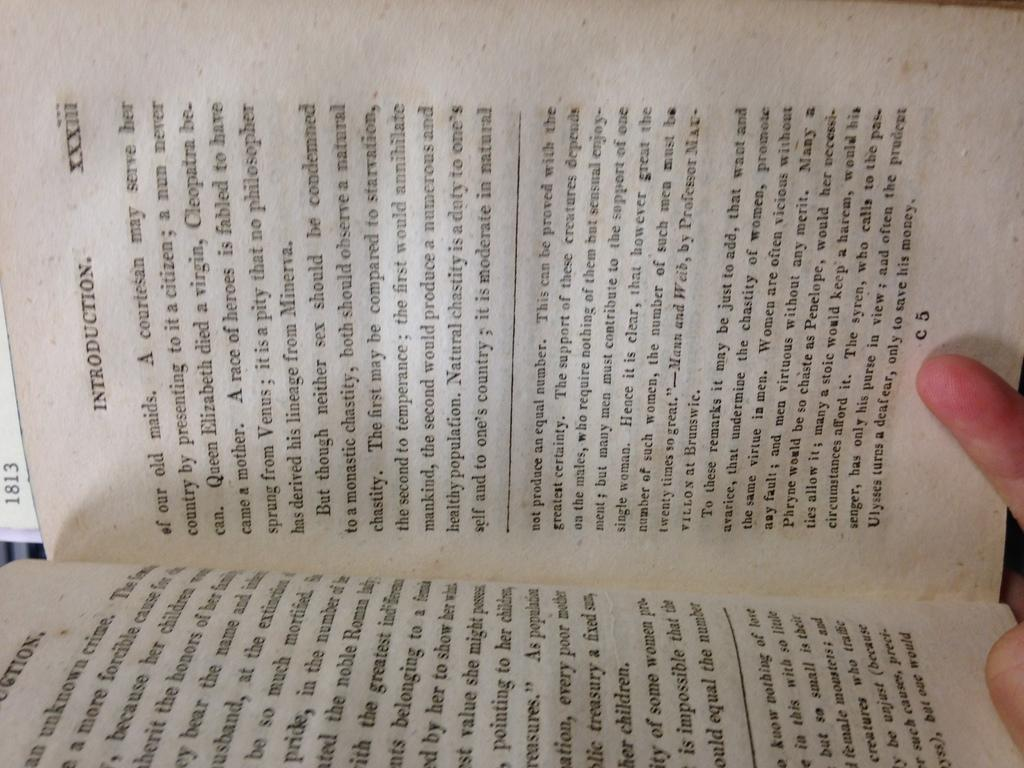<image>
Offer a succinct explanation of the picture presented. A book opened to the page with the introduction on it. 